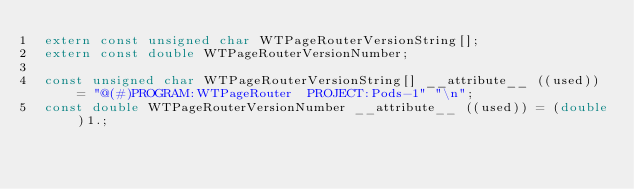Convert code to text. <code><loc_0><loc_0><loc_500><loc_500><_C_> extern const unsigned char WTPageRouterVersionString[];
 extern const double WTPageRouterVersionNumber;

 const unsigned char WTPageRouterVersionString[] __attribute__ ((used)) = "@(#)PROGRAM:WTPageRouter  PROJECT:Pods-1" "\n";
 const double WTPageRouterVersionNumber __attribute__ ((used)) = (double)1.;
</code> 